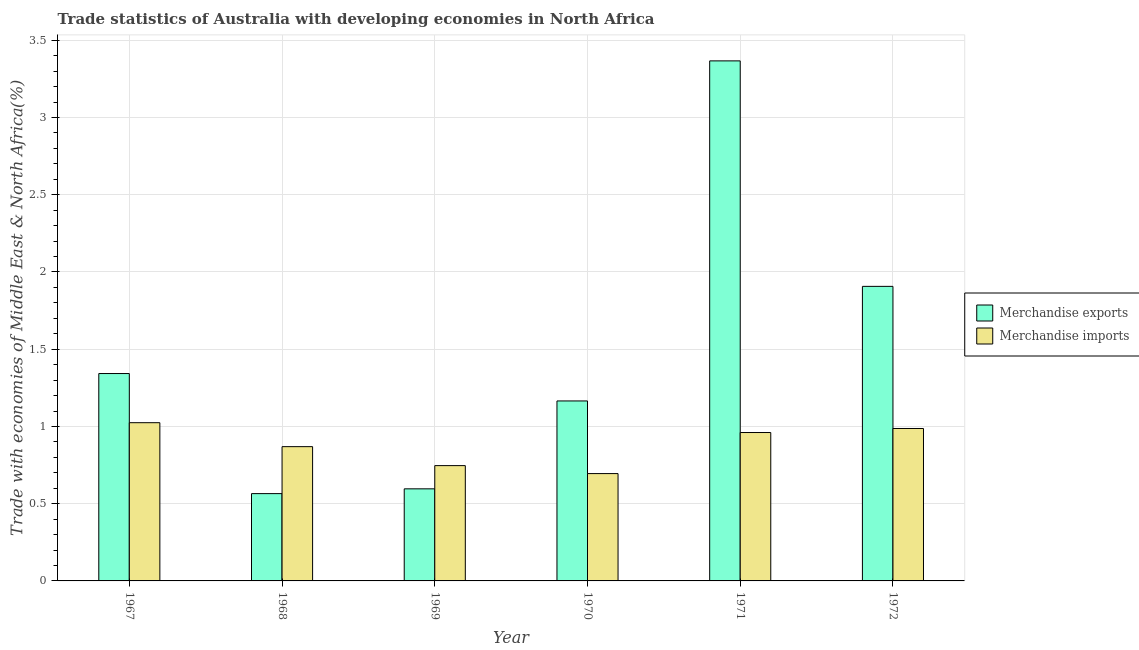Are the number of bars on each tick of the X-axis equal?
Your answer should be compact. Yes. How many bars are there on the 3rd tick from the right?
Offer a terse response. 2. In how many cases, is the number of bars for a given year not equal to the number of legend labels?
Ensure brevity in your answer.  0. What is the merchandise imports in 1970?
Provide a short and direct response. 0.69. Across all years, what is the maximum merchandise exports?
Make the answer very short. 3.37. Across all years, what is the minimum merchandise exports?
Ensure brevity in your answer.  0.57. In which year was the merchandise exports maximum?
Provide a short and direct response. 1971. In which year was the merchandise exports minimum?
Offer a very short reply. 1968. What is the total merchandise imports in the graph?
Your answer should be very brief. 5.28. What is the difference between the merchandise imports in 1971 and that in 1972?
Offer a very short reply. -0.03. What is the difference between the merchandise exports in 1968 and the merchandise imports in 1967?
Your response must be concise. -0.78. What is the average merchandise exports per year?
Offer a very short reply. 1.49. In the year 1970, what is the difference between the merchandise imports and merchandise exports?
Give a very brief answer. 0. What is the ratio of the merchandise imports in 1970 to that in 1971?
Ensure brevity in your answer.  0.72. Is the merchandise exports in 1970 less than that in 1972?
Keep it short and to the point. Yes. What is the difference between the highest and the second highest merchandise imports?
Ensure brevity in your answer.  0.04. What is the difference between the highest and the lowest merchandise imports?
Give a very brief answer. 0.33. In how many years, is the merchandise exports greater than the average merchandise exports taken over all years?
Your answer should be very brief. 2. Is the sum of the merchandise exports in 1968 and 1971 greater than the maximum merchandise imports across all years?
Offer a terse response. Yes. What does the 1st bar from the left in 1969 represents?
Keep it short and to the point. Merchandise exports. What does the 1st bar from the right in 1968 represents?
Ensure brevity in your answer.  Merchandise imports. How many bars are there?
Make the answer very short. 12. Are all the bars in the graph horizontal?
Your answer should be very brief. No. Does the graph contain grids?
Your response must be concise. Yes. How are the legend labels stacked?
Give a very brief answer. Vertical. What is the title of the graph?
Give a very brief answer. Trade statistics of Australia with developing economies in North Africa. What is the label or title of the X-axis?
Keep it short and to the point. Year. What is the label or title of the Y-axis?
Offer a very short reply. Trade with economies of Middle East & North Africa(%). What is the Trade with economies of Middle East & North Africa(%) in Merchandise exports in 1967?
Give a very brief answer. 1.34. What is the Trade with economies of Middle East & North Africa(%) of Merchandise imports in 1967?
Your response must be concise. 1.02. What is the Trade with economies of Middle East & North Africa(%) in Merchandise exports in 1968?
Your answer should be very brief. 0.57. What is the Trade with economies of Middle East & North Africa(%) in Merchandise imports in 1968?
Provide a succinct answer. 0.87. What is the Trade with economies of Middle East & North Africa(%) in Merchandise exports in 1969?
Provide a short and direct response. 0.6. What is the Trade with economies of Middle East & North Africa(%) in Merchandise imports in 1969?
Offer a terse response. 0.75. What is the Trade with economies of Middle East & North Africa(%) in Merchandise exports in 1970?
Your response must be concise. 1.17. What is the Trade with economies of Middle East & North Africa(%) of Merchandise imports in 1970?
Make the answer very short. 0.69. What is the Trade with economies of Middle East & North Africa(%) in Merchandise exports in 1971?
Keep it short and to the point. 3.37. What is the Trade with economies of Middle East & North Africa(%) of Merchandise imports in 1971?
Give a very brief answer. 0.96. What is the Trade with economies of Middle East & North Africa(%) of Merchandise exports in 1972?
Ensure brevity in your answer.  1.91. What is the Trade with economies of Middle East & North Africa(%) of Merchandise imports in 1972?
Make the answer very short. 0.99. Across all years, what is the maximum Trade with economies of Middle East & North Africa(%) of Merchandise exports?
Offer a terse response. 3.37. Across all years, what is the maximum Trade with economies of Middle East & North Africa(%) of Merchandise imports?
Provide a short and direct response. 1.02. Across all years, what is the minimum Trade with economies of Middle East & North Africa(%) in Merchandise exports?
Provide a short and direct response. 0.57. Across all years, what is the minimum Trade with economies of Middle East & North Africa(%) in Merchandise imports?
Provide a succinct answer. 0.69. What is the total Trade with economies of Middle East & North Africa(%) of Merchandise exports in the graph?
Offer a terse response. 8.94. What is the total Trade with economies of Middle East & North Africa(%) in Merchandise imports in the graph?
Make the answer very short. 5.28. What is the difference between the Trade with economies of Middle East & North Africa(%) in Merchandise exports in 1967 and that in 1968?
Provide a short and direct response. 0.78. What is the difference between the Trade with economies of Middle East & North Africa(%) in Merchandise imports in 1967 and that in 1968?
Ensure brevity in your answer.  0.16. What is the difference between the Trade with economies of Middle East & North Africa(%) of Merchandise exports in 1967 and that in 1969?
Give a very brief answer. 0.75. What is the difference between the Trade with economies of Middle East & North Africa(%) of Merchandise imports in 1967 and that in 1969?
Make the answer very short. 0.28. What is the difference between the Trade with economies of Middle East & North Africa(%) in Merchandise exports in 1967 and that in 1970?
Provide a short and direct response. 0.18. What is the difference between the Trade with economies of Middle East & North Africa(%) in Merchandise imports in 1967 and that in 1970?
Give a very brief answer. 0.33. What is the difference between the Trade with economies of Middle East & North Africa(%) in Merchandise exports in 1967 and that in 1971?
Make the answer very short. -2.02. What is the difference between the Trade with economies of Middle East & North Africa(%) in Merchandise imports in 1967 and that in 1971?
Give a very brief answer. 0.06. What is the difference between the Trade with economies of Middle East & North Africa(%) of Merchandise exports in 1967 and that in 1972?
Your response must be concise. -0.56. What is the difference between the Trade with economies of Middle East & North Africa(%) in Merchandise imports in 1967 and that in 1972?
Your answer should be very brief. 0.04. What is the difference between the Trade with economies of Middle East & North Africa(%) of Merchandise exports in 1968 and that in 1969?
Your response must be concise. -0.03. What is the difference between the Trade with economies of Middle East & North Africa(%) in Merchandise imports in 1968 and that in 1969?
Provide a succinct answer. 0.12. What is the difference between the Trade with economies of Middle East & North Africa(%) in Merchandise imports in 1968 and that in 1970?
Provide a short and direct response. 0.17. What is the difference between the Trade with economies of Middle East & North Africa(%) of Merchandise exports in 1968 and that in 1971?
Ensure brevity in your answer.  -2.8. What is the difference between the Trade with economies of Middle East & North Africa(%) of Merchandise imports in 1968 and that in 1971?
Give a very brief answer. -0.09. What is the difference between the Trade with economies of Middle East & North Africa(%) in Merchandise exports in 1968 and that in 1972?
Your answer should be compact. -1.34. What is the difference between the Trade with economies of Middle East & North Africa(%) of Merchandise imports in 1968 and that in 1972?
Make the answer very short. -0.12. What is the difference between the Trade with economies of Middle East & North Africa(%) of Merchandise exports in 1969 and that in 1970?
Your answer should be compact. -0.57. What is the difference between the Trade with economies of Middle East & North Africa(%) of Merchandise imports in 1969 and that in 1970?
Keep it short and to the point. 0.05. What is the difference between the Trade with economies of Middle East & North Africa(%) of Merchandise exports in 1969 and that in 1971?
Your answer should be compact. -2.77. What is the difference between the Trade with economies of Middle East & North Africa(%) in Merchandise imports in 1969 and that in 1971?
Your answer should be compact. -0.21. What is the difference between the Trade with economies of Middle East & North Africa(%) of Merchandise exports in 1969 and that in 1972?
Your answer should be very brief. -1.31. What is the difference between the Trade with economies of Middle East & North Africa(%) in Merchandise imports in 1969 and that in 1972?
Your answer should be very brief. -0.24. What is the difference between the Trade with economies of Middle East & North Africa(%) in Merchandise exports in 1970 and that in 1971?
Offer a terse response. -2.2. What is the difference between the Trade with economies of Middle East & North Africa(%) in Merchandise imports in 1970 and that in 1971?
Give a very brief answer. -0.27. What is the difference between the Trade with economies of Middle East & North Africa(%) of Merchandise exports in 1970 and that in 1972?
Make the answer very short. -0.74. What is the difference between the Trade with economies of Middle East & North Africa(%) in Merchandise imports in 1970 and that in 1972?
Give a very brief answer. -0.29. What is the difference between the Trade with economies of Middle East & North Africa(%) of Merchandise exports in 1971 and that in 1972?
Your response must be concise. 1.46. What is the difference between the Trade with economies of Middle East & North Africa(%) in Merchandise imports in 1971 and that in 1972?
Ensure brevity in your answer.  -0.03. What is the difference between the Trade with economies of Middle East & North Africa(%) in Merchandise exports in 1967 and the Trade with economies of Middle East & North Africa(%) in Merchandise imports in 1968?
Offer a terse response. 0.47. What is the difference between the Trade with economies of Middle East & North Africa(%) of Merchandise exports in 1967 and the Trade with economies of Middle East & North Africa(%) of Merchandise imports in 1969?
Your answer should be compact. 0.6. What is the difference between the Trade with economies of Middle East & North Africa(%) in Merchandise exports in 1967 and the Trade with economies of Middle East & North Africa(%) in Merchandise imports in 1970?
Provide a succinct answer. 0.65. What is the difference between the Trade with economies of Middle East & North Africa(%) in Merchandise exports in 1967 and the Trade with economies of Middle East & North Africa(%) in Merchandise imports in 1971?
Provide a short and direct response. 0.38. What is the difference between the Trade with economies of Middle East & North Africa(%) of Merchandise exports in 1967 and the Trade with economies of Middle East & North Africa(%) of Merchandise imports in 1972?
Offer a very short reply. 0.36. What is the difference between the Trade with economies of Middle East & North Africa(%) in Merchandise exports in 1968 and the Trade with economies of Middle East & North Africa(%) in Merchandise imports in 1969?
Offer a very short reply. -0.18. What is the difference between the Trade with economies of Middle East & North Africa(%) of Merchandise exports in 1968 and the Trade with economies of Middle East & North Africa(%) of Merchandise imports in 1970?
Offer a terse response. -0.13. What is the difference between the Trade with economies of Middle East & North Africa(%) in Merchandise exports in 1968 and the Trade with economies of Middle East & North Africa(%) in Merchandise imports in 1971?
Your response must be concise. -0.4. What is the difference between the Trade with economies of Middle East & North Africa(%) in Merchandise exports in 1968 and the Trade with economies of Middle East & North Africa(%) in Merchandise imports in 1972?
Give a very brief answer. -0.42. What is the difference between the Trade with economies of Middle East & North Africa(%) in Merchandise exports in 1969 and the Trade with economies of Middle East & North Africa(%) in Merchandise imports in 1970?
Your answer should be compact. -0.1. What is the difference between the Trade with economies of Middle East & North Africa(%) in Merchandise exports in 1969 and the Trade with economies of Middle East & North Africa(%) in Merchandise imports in 1971?
Your response must be concise. -0.36. What is the difference between the Trade with economies of Middle East & North Africa(%) in Merchandise exports in 1969 and the Trade with economies of Middle East & North Africa(%) in Merchandise imports in 1972?
Ensure brevity in your answer.  -0.39. What is the difference between the Trade with economies of Middle East & North Africa(%) in Merchandise exports in 1970 and the Trade with economies of Middle East & North Africa(%) in Merchandise imports in 1971?
Keep it short and to the point. 0.2. What is the difference between the Trade with economies of Middle East & North Africa(%) in Merchandise exports in 1970 and the Trade with economies of Middle East & North Africa(%) in Merchandise imports in 1972?
Give a very brief answer. 0.18. What is the difference between the Trade with economies of Middle East & North Africa(%) in Merchandise exports in 1971 and the Trade with economies of Middle East & North Africa(%) in Merchandise imports in 1972?
Your answer should be very brief. 2.38. What is the average Trade with economies of Middle East & North Africa(%) in Merchandise exports per year?
Offer a very short reply. 1.49. What is the average Trade with economies of Middle East & North Africa(%) in Merchandise imports per year?
Your answer should be very brief. 0.88. In the year 1967, what is the difference between the Trade with economies of Middle East & North Africa(%) in Merchandise exports and Trade with economies of Middle East & North Africa(%) in Merchandise imports?
Keep it short and to the point. 0.32. In the year 1968, what is the difference between the Trade with economies of Middle East & North Africa(%) in Merchandise exports and Trade with economies of Middle East & North Africa(%) in Merchandise imports?
Offer a very short reply. -0.3. In the year 1969, what is the difference between the Trade with economies of Middle East & North Africa(%) in Merchandise exports and Trade with economies of Middle East & North Africa(%) in Merchandise imports?
Provide a short and direct response. -0.15. In the year 1970, what is the difference between the Trade with economies of Middle East & North Africa(%) of Merchandise exports and Trade with economies of Middle East & North Africa(%) of Merchandise imports?
Make the answer very short. 0.47. In the year 1971, what is the difference between the Trade with economies of Middle East & North Africa(%) in Merchandise exports and Trade with economies of Middle East & North Africa(%) in Merchandise imports?
Offer a terse response. 2.41. What is the ratio of the Trade with economies of Middle East & North Africa(%) in Merchandise exports in 1967 to that in 1968?
Offer a very short reply. 2.38. What is the ratio of the Trade with economies of Middle East & North Africa(%) in Merchandise imports in 1967 to that in 1968?
Ensure brevity in your answer.  1.18. What is the ratio of the Trade with economies of Middle East & North Africa(%) in Merchandise exports in 1967 to that in 1969?
Ensure brevity in your answer.  2.25. What is the ratio of the Trade with economies of Middle East & North Africa(%) in Merchandise imports in 1967 to that in 1969?
Offer a terse response. 1.37. What is the ratio of the Trade with economies of Middle East & North Africa(%) in Merchandise exports in 1967 to that in 1970?
Your answer should be compact. 1.15. What is the ratio of the Trade with economies of Middle East & North Africa(%) in Merchandise imports in 1967 to that in 1970?
Your answer should be very brief. 1.47. What is the ratio of the Trade with economies of Middle East & North Africa(%) in Merchandise exports in 1967 to that in 1971?
Provide a succinct answer. 0.4. What is the ratio of the Trade with economies of Middle East & North Africa(%) of Merchandise imports in 1967 to that in 1971?
Provide a short and direct response. 1.07. What is the ratio of the Trade with economies of Middle East & North Africa(%) of Merchandise exports in 1967 to that in 1972?
Offer a very short reply. 0.7. What is the ratio of the Trade with economies of Middle East & North Africa(%) in Merchandise imports in 1967 to that in 1972?
Keep it short and to the point. 1.04. What is the ratio of the Trade with economies of Middle East & North Africa(%) in Merchandise exports in 1968 to that in 1969?
Your answer should be very brief. 0.95. What is the ratio of the Trade with economies of Middle East & North Africa(%) of Merchandise imports in 1968 to that in 1969?
Keep it short and to the point. 1.16. What is the ratio of the Trade with economies of Middle East & North Africa(%) of Merchandise exports in 1968 to that in 1970?
Keep it short and to the point. 0.49. What is the ratio of the Trade with economies of Middle East & North Africa(%) of Merchandise imports in 1968 to that in 1970?
Provide a short and direct response. 1.25. What is the ratio of the Trade with economies of Middle East & North Africa(%) of Merchandise exports in 1968 to that in 1971?
Ensure brevity in your answer.  0.17. What is the ratio of the Trade with economies of Middle East & North Africa(%) in Merchandise imports in 1968 to that in 1971?
Offer a very short reply. 0.9. What is the ratio of the Trade with economies of Middle East & North Africa(%) of Merchandise exports in 1968 to that in 1972?
Keep it short and to the point. 0.3. What is the ratio of the Trade with economies of Middle East & North Africa(%) of Merchandise imports in 1968 to that in 1972?
Your answer should be compact. 0.88. What is the ratio of the Trade with economies of Middle East & North Africa(%) in Merchandise exports in 1969 to that in 1970?
Your answer should be compact. 0.51. What is the ratio of the Trade with economies of Middle East & North Africa(%) in Merchandise imports in 1969 to that in 1970?
Your answer should be very brief. 1.07. What is the ratio of the Trade with economies of Middle East & North Africa(%) in Merchandise exports in 1969 to that in 1971?
Offer a terse response. 0.18. What is the ratio of the Trade with economies of Middle East & North Africa(%) in Merchandise imports in 1969 to that in 1971?
Make the answer very short. 0.78. What is the ratio of the Trade with economies of Middle East & North Africa(%) in Merchandise exports in 1969 to that in 1972?
Provide a succinct answer. 0.31. What is the ratio of the Trade with economies of Middle East & North Africa(%) of Merchandise imports in 1969 to that in 1972?
Offer a very short reply. 0.76. What is the ratio of the Trade with economies of Middle East & North Africa(%) of Merchandise exports in 1970 to that in 1971?
Offer a very short reply. 0.35. What is the ratio of the Trade with economies of Middle East & North Africa(%) in Merchandise imports in 1970 to that in 1971?
Offer a terse response. 0.72. What is the ratio of the Trade with economies of Middle East & North Africa(%) of Merchandise exports in 1970 to that in 1972?
Your answer should be very brief. 0.61. What is the ratio of the Trade with economies of Middle East & North Africa(%) of Merchandise imports in 1970 to that in 1972?
Your answer should be very brief. 0.7. What is the ratio of the Trade with economies of Middle East & North Africa(%) of Merchandise exports in 1971 to that in 1972?
Ensure brevity in your answer.  1.77. What is the ratio of the Trade with economies of Middle East & North Africa(%) of Merchandise imports in 1971 to that in 1972?
Ensure brevity in your answer.  0.97. What is the difference between the highest and the second highest Trade with economies of Middle East & North Africa(%) in Merchandise exports?
Your response must be concise. 1.46. What is the difference between the highest and the second highest Trade with economies of Middle East & North Africa(%) in Merchandise imports?
Offer a terse response. 0.04. What is the difference between the highest and the lowest Trade with economies of Middle East & North Africa(%) of Merchandise exports?
Your response must be concise. 2.8. What is the difference between the highest and the lowest Trade with economies of Middle East & North Africa(%) in Merchandise imports?
Give a very brief answer. 0.33. 